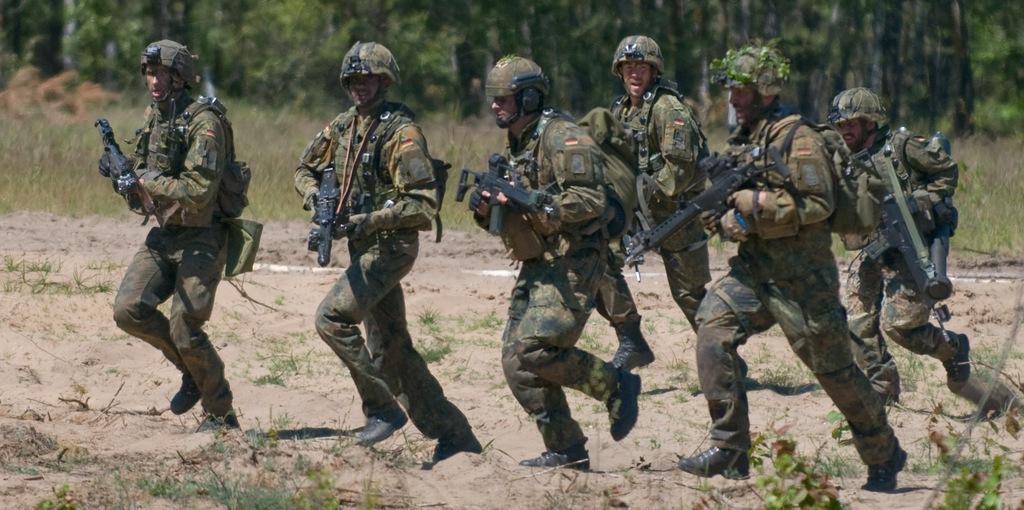Could you give a brief overview of what you see in this image? In the image we can see there are people standing and they are holding rifles in their hand. They are wearing helmets and behind there are lot of trees. 